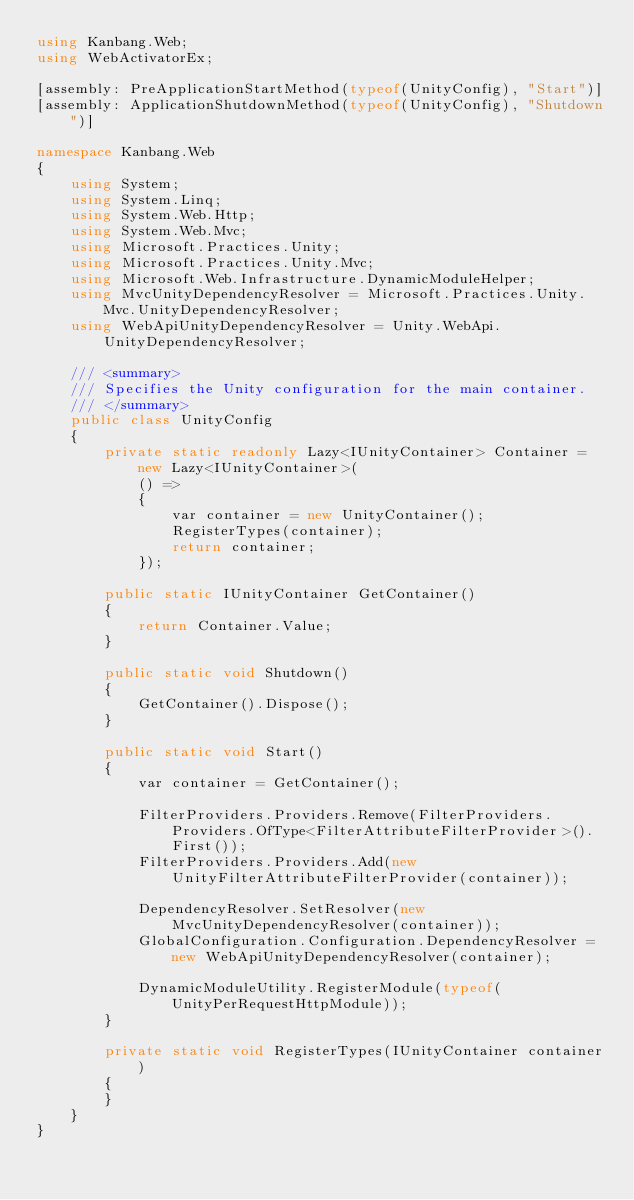<code> <loc_0><loc_0><loc_500><loc_500><_C#_>using Kanbang.Web;
using WebActivatorEx;

[assembly: PreApplicationStartMethod(typeof(UnityConfig), "Start")]
[assembly: ApplicationShutdownMethod(typeof(UnityConfig), "Shutdown")]

namespace Kanbang.Web
{
	using System;
	using System.Linq;
	using System.Web.Http;
	using System.Web.Mvc;
	using Microsoft.Practices.Unity;
	using Microsoft.Practices.Unity.Mvc;
	using Microsoft.Web.Infrastructure.DynamicModuleHelper;
	using MvcUnityDependencyResolver = Microsoft.Practices.Unity.Mvc.UnityDependencyResolver;
	using WebApiUnityDependencyResolver = Unity.WebApi.UnityDependencyResolver;

	/// <summary>
	/// Specifies the Unity configuration for the main container.
	/// </summary>
	public class UnityConfig
	{
		private static readonly Lazy<IUnityContainer> Container = new Lazy<IUnityContainer>(
			() =>
			{
				var container = new UnityContainer();
				RegisterTypes(container);
				return container;
			});

		public static IUnityContainer GetContainer()
		{
			return Container.Value;
		}

		public static void Shutdown()
		{
			GetContainer().Dispose();
		}

		public static void Start()
		{
			var container = GetContainer();

			FilterProviders.Providers.Remove(FilterProviders.Providers.OfType<FilterAttributeFilterProvider>().First());
			FilterProviders.Providers.Add(new UnityFilterAttributeFilterProvider(container));

			DependencyResolver.SetResolver(new MvcUnityDependencyResolver(container));
			GlobalConfiguration.Configuration.DependencyResolver = new WebApiUnityDependencyResolver(container);

			DynamicModuleUtility.RegisterModule(typeof(UnityPerRequestHttpModule));
		}

		private static void RegisterTypes(IUnityContainer container)
		{
		}
	}
}</code> 